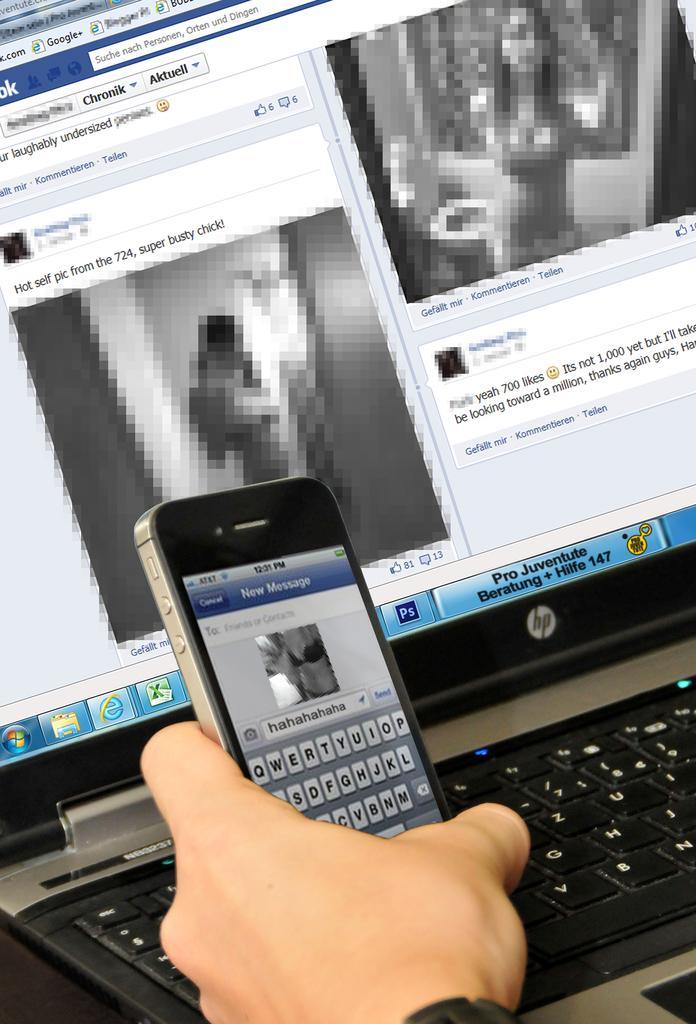Could you give a brief overview of what you see in this image? Here we can see hand of a person holding a mobile and there is a laptop. 